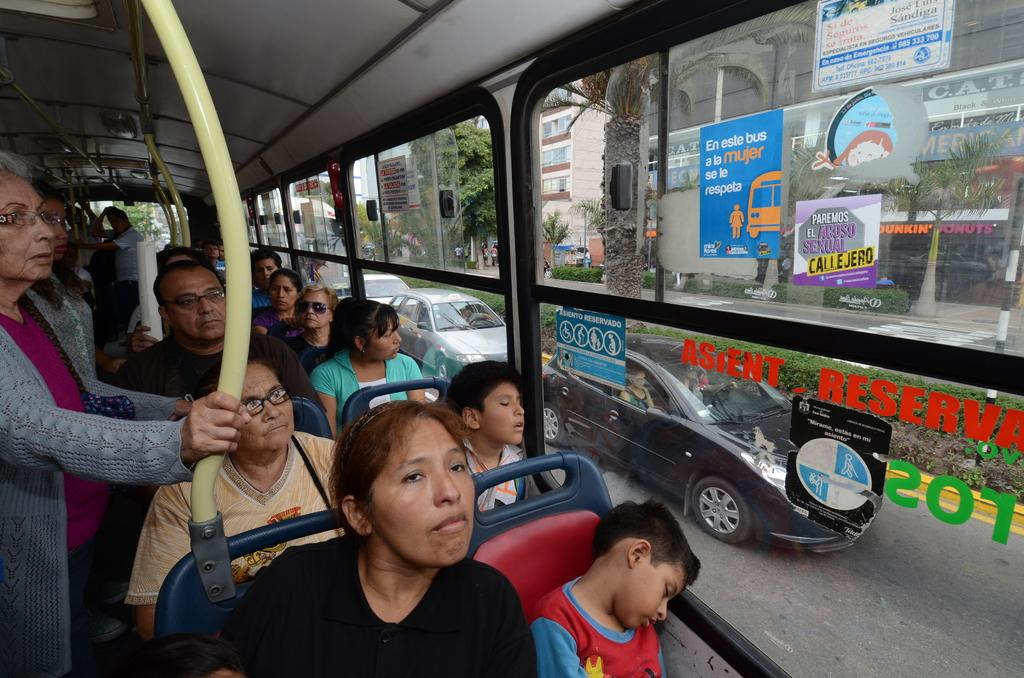What mode of transportation are the people in the image using? The people are sitting in a bus. Are there any standing passengers in the bus? Yes, two persons are standing. What type of window is present in the bus? There is a glass window in the bus. What can be seen through the window? Vehicles on the road, buildings, trees, and plants can be seen through the window. How does the bus increase its speed while the beginner driver is learning to drive? The image does not provide information about the bus's speed or the driver's experience level, so it cannot be determined from the image. 